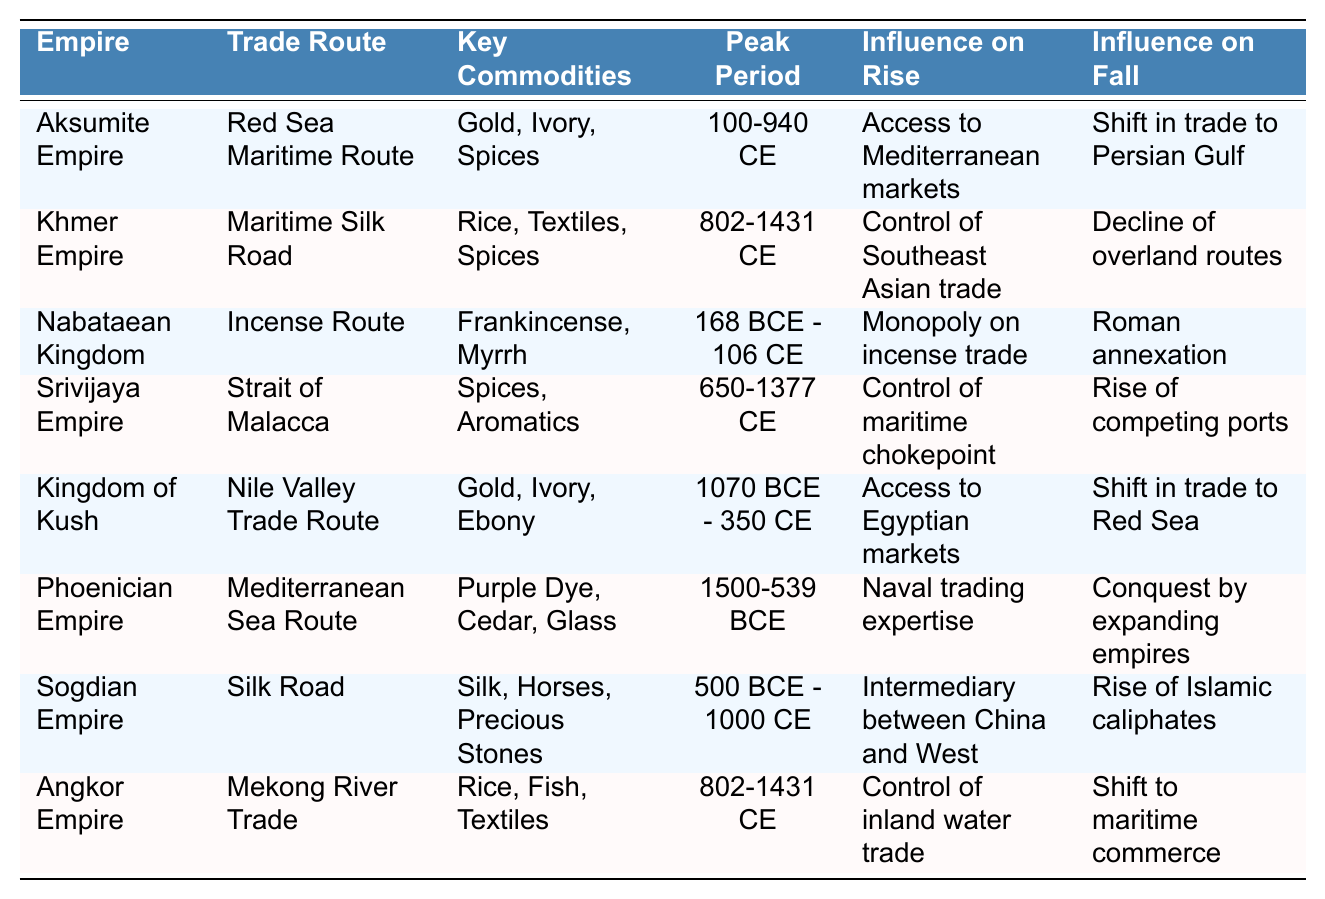What was the peak period of the Aksumite Empire? The table lists the peak period of the Aksumite Empire as 100-940 CE.
Answer: 100-940 CE Which empire controlled the maritime chokepoint? The Srivijaya Empire is indicated in the table to have controlled the maritime chokepoint during its peak.
Answer: Srivijaya Empire Did the Kingdom of Kush access the Egyptian markets? According to the table, the Kingdom of Kush had access to Egyptian markets, so the answer is yes.
Answer: Yes What key commodities did the Phoenician Empire trade? The Phoenician Empire traded purple dye, cedar, and glass, as listed in the table under key commodities.
Answer: Purple Dye, Cedar, Glass Which empire experienced a decline due to the rise of competing ports? The Srivijaya Empire faced a decline due to the rise of competing ports, per the table.
Answer: Srivijaya Empire What was the influence on the fall of the Khmer Empire? The table indicates that the decline of overland routes influenced the fall of the Khmer Empire.
Answer: Decline of overland routes How many empires shared a peak period of 802-1431 CE? The table shows that two empires, the Khmer Empire and Angkor Empire, shared the peak period of 802-1431 CE.
Answer: 2 Which key commodities were traded along the Silk Road? The Sogdian Empire is recorded in the table as trading silk, horses, and precious stones along the Silk Road.
Answer: Silk, Horses, Precious Stones Between which trade routes did the Aksumite Empire and the Kingdom of Kush differ? The Aksumite Empire utilized the Red Sea Maritime Route, while the Kingdom of Kush relied on the Nile Valley Trade Route, indicating their different trade routes.
Answer: Red Sea Maritime Route and Nile Valley Trade Route What was the effect of the Roman annexation on the Nabataean Kingdom? The table states that the Roman annexation led to the fall of the Nabataean Kingdom, implying that the influence was detrimental.
Answer: Detrimental influence 